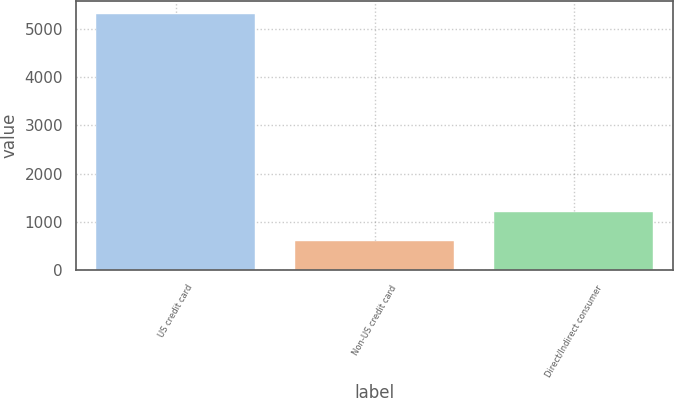Convert chart. <chart><loc_0><loc_0><loc_500><loc_500><bar_chart><fcel>US credit card<fcel>Non-US credit card<fcel>Direct/Indirect consumer<nl><fcel>5305<fcel>597<fcel>1198<nl></chart> 